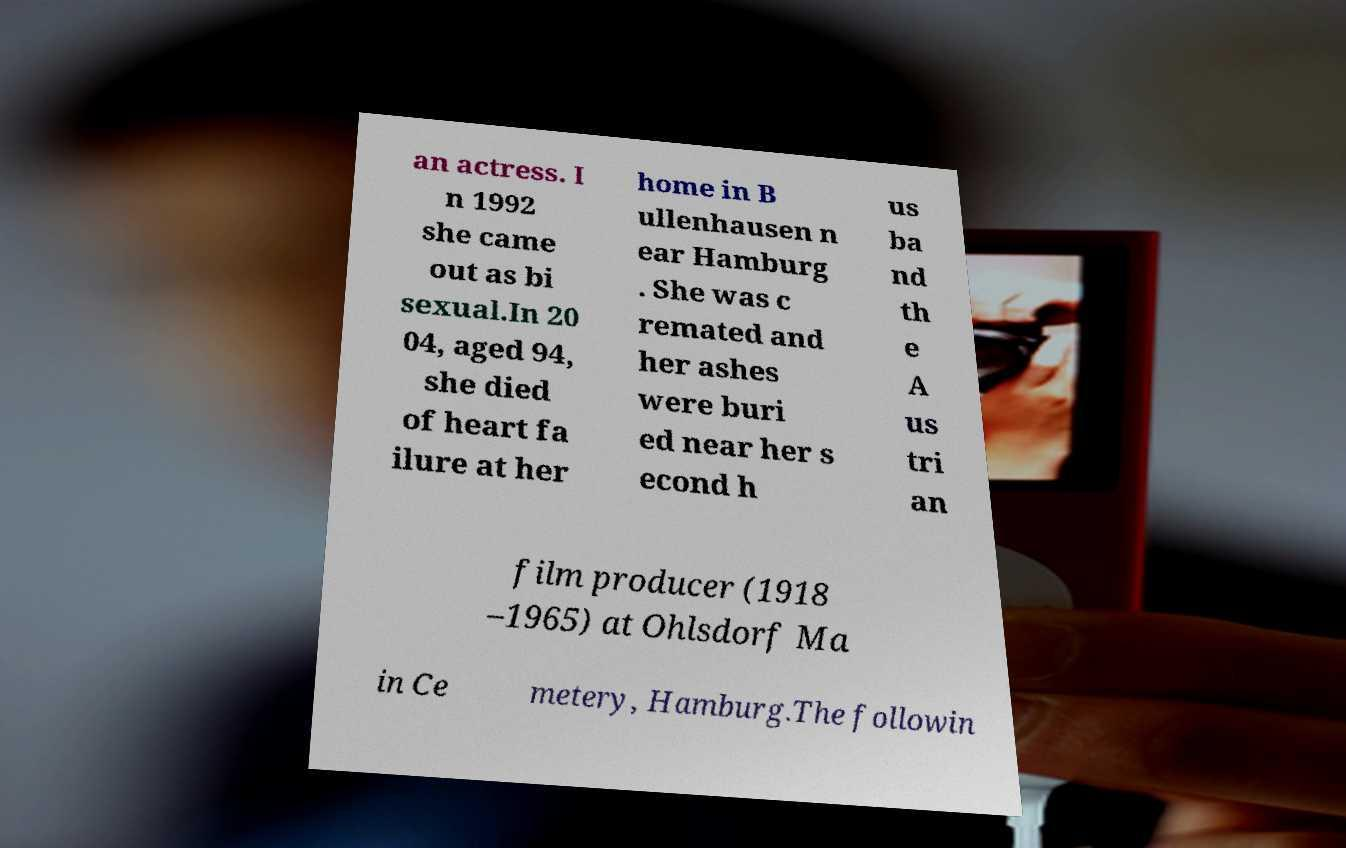Please read and relay the text visible in this image. What does it say? an actress. I n 1992 she came out as bi sexual.In 20 04, aged 94, she died of heart fa ilure at her home in B ullenhausen n ear Hamburg . She was c remated and her ashes were buri ed near her s econd h us ba nd th e A us tri an film producer (1918 –1965) at Ohlsdorf Ma in Ce metery, Hamburg.The followin 